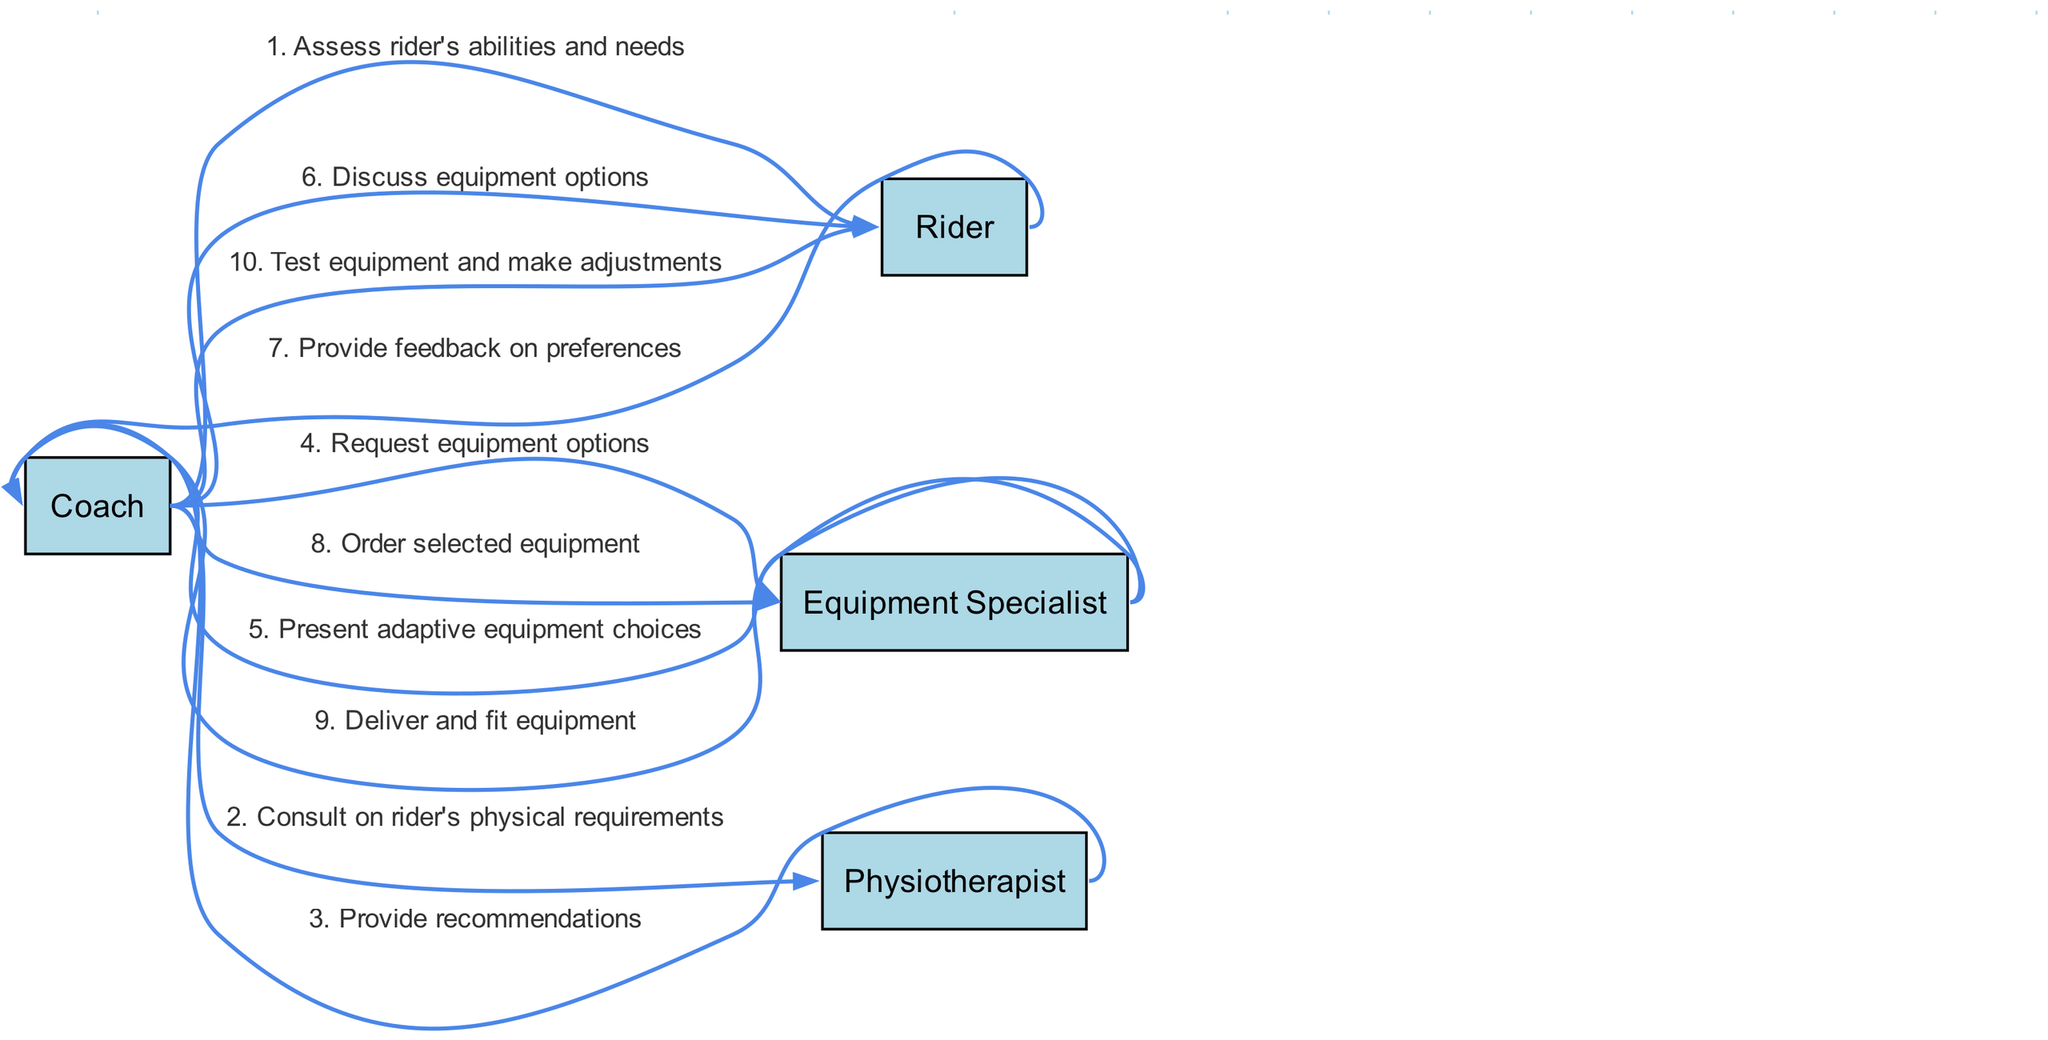What is the first action taken by the Coach? The sequence diagram shows that the first action taken by the Coach is to "Assess rider's abilities and needs." This is the first message in the order of interactions depicted.
Answer: Assess rider's abilities and needs How many actors are involved in the decision-making process? The diagram lists four actors: Coach, Rider, Equipment Specialist, and Physiotherapist. Thus, the total number of actors is derived from counting these unique entities in the actor list.
Answer: Four Which actor provides recommendations to the Coach? According to the sequence diagram, the Physiotherapist provides recommendations. This is indicated in the third step where the Physiotherapist communicates back to the Coach.
Answer: Physiotherapist What is the last step in the sequence? The last step in the sequence diagram is when the Coach "Test equipment and make adjustments." This is designated as the final interaction before the process concludes.
Answer: Test equipment and make adjustments How many messages are exchanged between the Coach and Equipment Specialist? The diagram illustrates two messages exchanged between the Coach and the Equipment Specialist: one where the Coach requests equipment options, and another where the Equipment Specialist presents adaptive equipment choices. So, by counting these interactions, the total comes to two.
Answer: Two Who provides feedback on preferences and to whom? The Rider provides feedback on preferences to the Coach. This interaction is highlighted in the sequence, showing the Rider responding after the Coach discusses equipment options.
Answer: Rider to Coach What action follows after the Equipment Specialist delivers the equipment? Once the Equipment Specialist delivers and fits the equipment, the next action taken is by the Coach to "Test equipment and make adjustments." This follows sequentially in the flow of actions.
Answer: Test equipment and make adjustments Which actor does the Coach consult with regarding the rider's physical requirements? The Coach consults with the Physiotherapist regarding the rider's physical requirements. This is indicated in the interaction where the Coach reaches out to the Physiotherapist for advice.
Answer: Physiotherapist What action does the Rider take after discussing equipment options with the Coach? After discussing equipment options with the Coach, the Rider provides feedback on preferences. This is the step immediately following their discussion in the sequential flow.
Answer: Provide feedback on preferences 